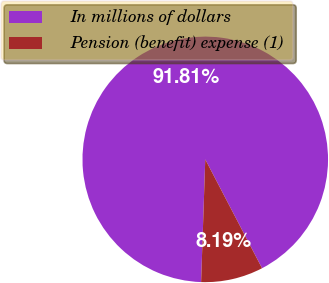Convert chart. <chart><loc_0><loc_0><loc_500><loc_500><pie_chart><fcel>In millions of dollars<fcel>Pension (benefit) expense (1)<nl><fcel>91.81%<fcel>8.19%<nl></chart> 